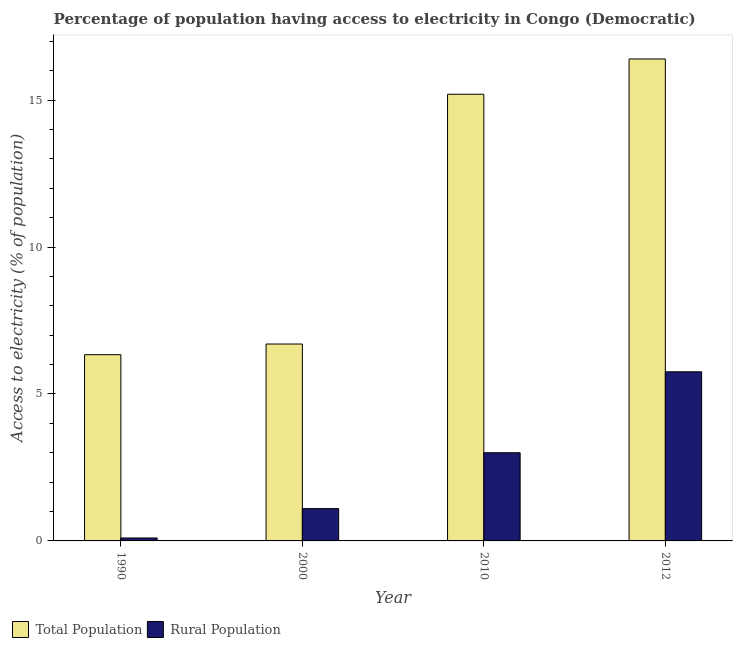Are the number of bars per tick equal to the number of legend labels?
Your response must be concise. Yes. Are the number of bars on each tick of the X-axis equal?
Offer a terse response. Yes. How many bars are there on the 4th tick from the left?
Keep it short and to the point. 2. How many bars are there on the 2nd tick from the right?
Your response must be concise. 2. Across all years, what is the maximum percentage of population having access to electricity?
Ensure brevity in your answer.  16.4. Across all years, what is the minimum percentage of population having access to electricity?
Keep it short and to the point. 6.34. In which year was the percentage of population having access to electricity maximum?
Your answer should be compact. 2012. In which year was the percentage of rural population having access to electricity minimum?
Provide a succinct answer. 1990. What is the total percentage of population having access to electricity in the graph?
Offer a terse response. 44.64. What is the difference between the percentage of rural population having access to electricity in 1990 and that in 2012?
Keep it short and to the point. -5.65. What is the average percentage of population having access to electricity per year?
Provide a succinct answer. 11.16. In the year 1990, what is the difference between the percentage of rural population having access to electricity and percentage of population having access to electricity?
Make the answer very short. 0. In how many years, is the percentage of rural population having access to electricity greater than 12 %?
Your answer should be compact. 0. What is the ratio of the percentage of population having access to electricity in 2000 to that in 2010?
Your answer should be compact. 0.44. What is the difference between the highest and the second highest percentage of population having access to electricity?
Provide a succinct answer. 1.2. What is the difference between the highest and the lowest percentage of rural population having access to electricity?
Your response must be concise. 5.65. In how many years, is the percentage of population having access to electricity greater than the average percentage of population having access to electricity taken over all years?
Make the answer very short. 2. Is the sum of the percentage of population having access to electricity in 1990 and 2000 greater than the maximum percentage of rural population having access to electricity across all years?
Offer a very short reply. No. What does the 1st bar from the left in 2010 represents?
Your answer should be compact. Total Population. What does the 2nd bar from the right in 1990 represents?
Your answer should be very brief. Total Population. Are all the bars in the graph horizontal?
Give a very brief answer. No. Are the values on the major ticks of Y-axis written in scientific E-notation?
Your answer should be very brief. No. Does the graph contain any zero values?
Your response must be concise. No. Where does the legend appear in the graph?
Your answer should be compact. Bottom left. How many legend labels are there?
Your answer should be very brief. 2. What is the title of the graph?
Your response must be concise. Percentage of population having access to electricity in Congo (Democratic). What is the label or title of the Y-axis?
Give a very brief answer. Access to electricity (% of population). What is the Access to electricity (% of population) in Total Population in 1990?
Provide a short and direct response. 6.34. What is the Access to electricity (% of population) of Rural Population in 2000?
Your answer should be compact. 1.1. What is the Access to electricity (% of population) of Total Population in 2010?
Make the answer very short. 15.2. What is the Access to electricity (% of population) of Rural Population in 2012?
Provide a succinct answer. 5.75. Across all years, what is the maximum Access to electricity (% of population) of Total Population?
Ensure brevity in your answer.  16.4. Across all years, what is the maximum Access to electricity (% of population) in Rural Population?
Offer a very short reply. 5.75. Across all years, what is the minimum Access to electricity (% of population) in Total Population?
Offer a very short reply. 6.34. What is the total Access to electricity (% of population) in Total Population in the graph?
Offer a terse response. 44.64. What is the total Access to electricity (% of population) in Rural Population in the graph?
Provide a succinct answer. 9.95. What is the difference between the Access to electricity (% of population) in Total Population in 1990 and that in 2000?
Ensure brevity in your answer.  -0.36. What is the difference between the Access to electricity (% of population) of Rural Population in 1990 and that in 2000?
Your answer should be compact. -1. What is the difference between the Access to electricity (% of population) in Total Population in 1990 and that in 2010?
Keep it short and to the point. -8.86. What is the difference between the Access to electricity (% of population) of Total Population in 1990 and that in 2012?
Your response must be concise. -10.06. What is the difference between the Access to electricity (% of population) of Rural Population in 1990 and that in 2012?
Your response must be concise. -5.65. What is the difference between the Access to electricity (% of population) in Rural Population in 2000 and that in 2010?
Your response must be concise. -1.9. What is the difference between the Access to electricity (% of population) of Rural Population in 2000 and that in 2012?
Ensure brevity in your answer.  -4.65. What is the difference between the Access to electricity (% of population) of Total Population in 2010 and that in 2012?
Keep it short and to the point. -1.2. What is the difference between the Access to electricity (% of population) of Rural Population in 2010 and that in 2012?
Your response must be concise. -2.75. What is the difference between the Access to electricity (% of population) of Total Population in 1990 and the Access to electricity (% of population) of Rural Population in 2000?
Offer a terse response. 5.24. What is the difference between the Access to electricity (% of population) in Total Population in 1990 and the Access to electricity (% of population) in Rural Population in 2010?
Your answer should be compact. 3.34. What is the difference between the Access to electricity (% of population) of Total Population in 1990 and the Access to electricity (% of population) of Rural Population in 2012?
Offer a terse response. 0.58. What is the difference between the Access to electricity (% of population) of Total Population in 2000 and the Access to electricity (% of population) of Rural Population in 2012?
Your response must be concise. 0.95. What is the difference between the Access to electricity (% of population) in Total Population in 2010 and the Access to electricity (% of population) in Rural Population in 2012?
Make the answer very short. 9.45. What is the average Access to electricity (% of population) in Total Population per year?
Provide a short and direct response. 11.16. What is the average Access to electricity (% of population) in Rural Population per year?
Provide a short and direct response. 2.49. In the year 1990, what is the difference between the Access to electricity (% of population) in Total Population and Access to electricity (% of population) in Rural Population?
Provide a short and direct response. 6.24. In the year 2010, what is the difference between the Access to electricity (% of population) of Total Population and Access to electricity (% of population) of Rural Population?
Offer a very short reply. 12.2. In the year 2012, what is the difference between the Access to electricity (% of population) of Total Population and Access to electricity (% of population) of Rural Population?
Offer a very short reply. 10.65. What is the ratio of the Access to electricity (% of population) in Total Population in 1990 to that in 2000?
Your answer should be compact. 0.95. What is the ratio of the Access to electricity (% of population) of Rural Population in 1990 to that in 2000?
Your response must be concise. 0.09. What is the ratio of the Access to electricity (% of population) of Total Population in 1990 to that in 2010?
Your response must be concise. 0.42. What is the ratio of the Access to electricity (% of population) in Rural Population in 1990 to that in 2010?
Your answer should be very brief. 0.03. What is the ratio of the Access to electricity (% of population) of Total Population in 1990 to that in 2012?
Offer a very short reply. 0.39. What is the ratio of the Access to electricity (% of population) of Rural Population in 1990 to that in 2012?
Ensure brevity in your answer.  0.02. What is the ratio of the Access to electricity (% of population) of Total Population in 2000 to that in 2010?
Provide a short and direct response. 0.44. What is the ratio of the Access to electricity (% of population) of Rural Population in 2000 to that in 2010?
Your answer should be compact. 0.37. What is the ratio of the Access to electricity (% of population) of Total Population in 2000 to that in 2012?
Your answer should be very brief. 0.41. What is the ratio of the Access to electricity (% of population) in Rural Population in 2000 to that in 2012?
Your response must be concise. 0.19. What is the ratio of the Access to electricity (% of population) in Total Population in 2010 to that in 2012?
Your answer should be very brief. 0.93. What is the ratio of the Access to electricity (% of population) in Rural Population in 2010 to that in 2012?
Give a very brief answer. 0.52. What is the difference between the highest and the second highest Access to electricity (% of population) in Total Population?
Make the answer very short. 1.2. What is the difference between the highest and the second highest Access to electricity (% of population) of Rural Population?
Keep it short and to the point. 2.75. What is the difference between the highest and the lowest Access to electricity (% of population) of Total Population?
Your answer should be compact. 10.06. What is the difference between the highest and the lowest Access to electricity (% of population) in Rural Population?
Provide a succinct answer. 5.65. 